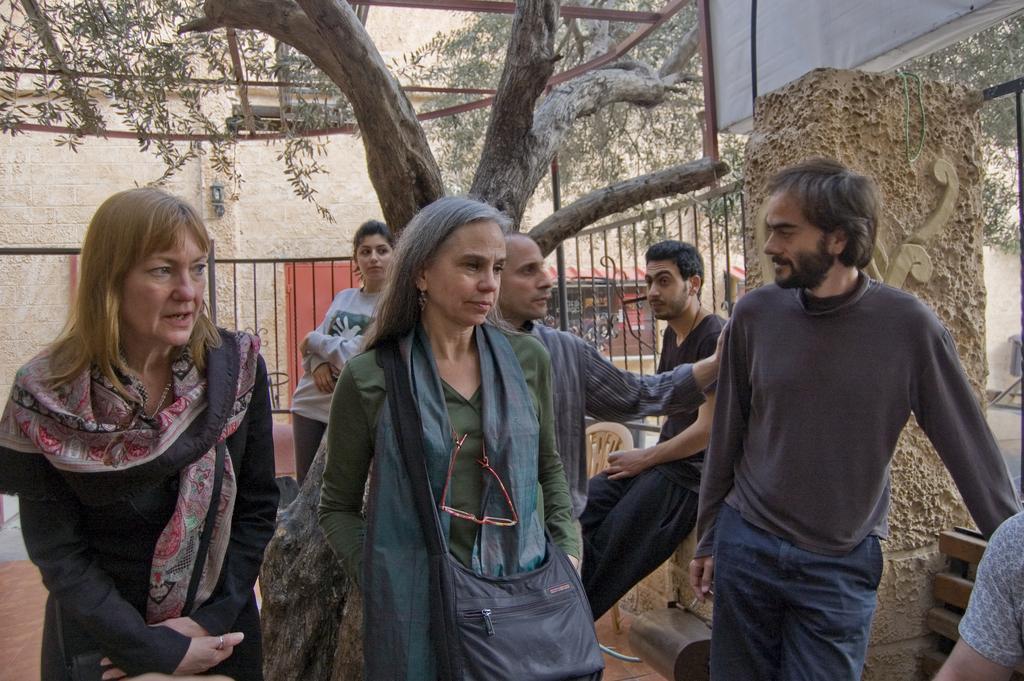Could you give a brief overview of what you see in this image? In this image I can see a group of people are standing on the floor. In the background I can see a fence, pillar, board, trees, building wall and metal rods. This image is taken may be during a day. 